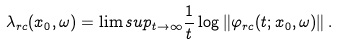<formula> <loc_0><loc_0><loc_500><loc_500>\lambda _ { r c } ( x _ { 0 } , \omega ) = \lim s u p _ { t \to \infty } \frac { 1 } { t } \log \left \| \varphi _ { r c } ( t ; x _ { 0 } , \omega ) \right \| .</formula> 